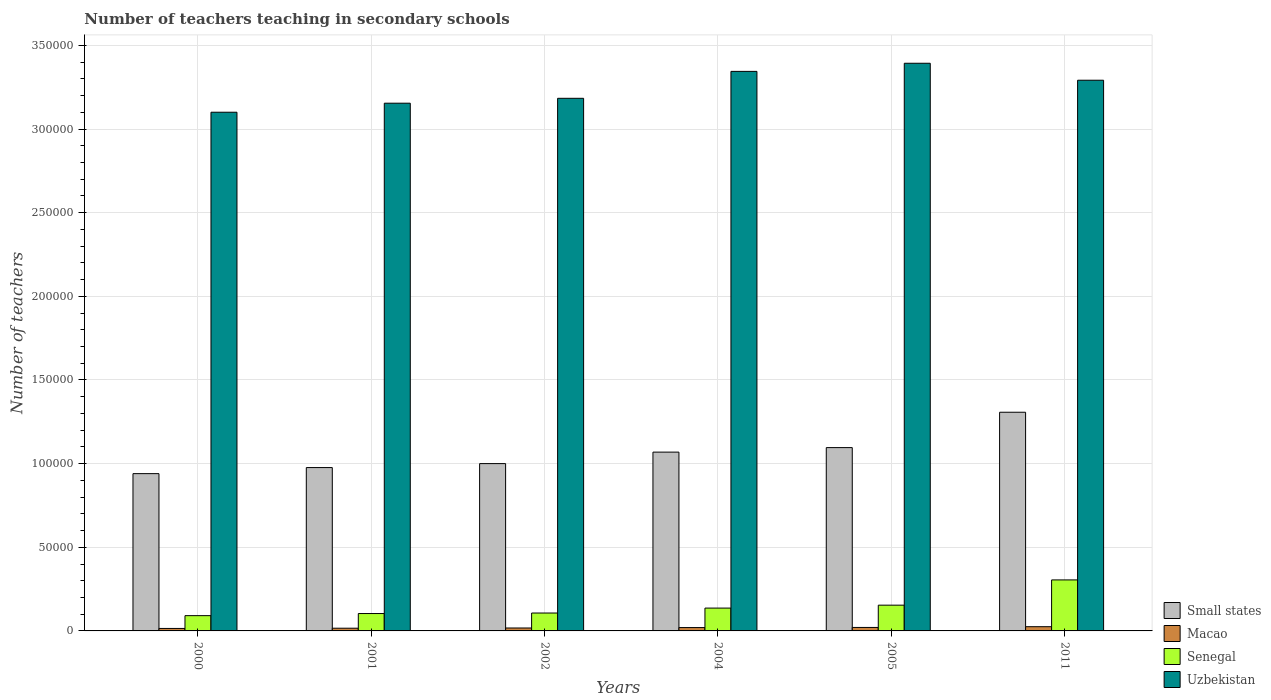How many different coloured bars are there?
Provide a short and direct response. 4. How many bars are there on the 2nd tick from the left?
Provide a short and direct response. 4. What is the number of teachers teaching in secondary schools in Small states in 2001?
Provide a short and direct response. 9.76e+04. Across all years, what is the maximum number of teachers teaching in secondary schools in Small states?
Your answer should be very brief. 1.31e+05. Across all years, what is the minimum number of teachers teaching in secondary schools in Uzbekistan?
Give a very brief answer. 3.10e+05. What is the total number of teachers teaching in secondary schools in Uzbekistan in the graph?
Offer a very short reply. 1.95e+06. What is the difference between the number of teachers teaching in secondary schools in Macao in 2001 and that in 2011?
Offer a very short reply. -902. What is the difference between the number of teachers teaching in secondary schools in Senegal in 2005 and the number of teachers teaching in secondary schools in Macao in 2004?
Your response must be concise. 1.34e+04. What is the average number of teachers teaching in secondary schools in Senegal per year?
Ensure brevity in your answer.  1.50e+04. In the year 2005, what is the difference between the number of teachers teaching in secondary schools in Macao and number of teachers teaching in secondary schools in Senegal?
Your response must be concise. -1.33e+04. In how many years, is the number of teachers teaching in secondary schools in Macao greater than 20000?
Offer a terse response. 0. What is the ratio of the number of teachers teaching in secondary schools in Small states in 2000 to that in 2005?
Offer a very short reply. 0.86. What is the difference between the highest and the second highest number of teachers teaching in secondary schools in Small states?
Keep it short and to the point. 2.11e+04. What is the difference between the highest and the lowest number of teachers teaching in secondary schools in Uzbekistan?
Provide a short and direct response. 2.93e+04. In how many years, is the number of teachers teaching in secondary schools in Macao greater than the average number of teachers teaching in secondary schools in Macao taken over all years?
Keep it short and to the point. 3. What does the 3rd bar from the left in 2000 represents?
Keep it short and to the point. Senegal. What does the 3rd bar from the right in 2000 represents?
Keep it short and to the point. Macao. Is it the case that in every year, the sum of the number of teachers teaching in secondary schools in Small states and number of teachers teaching in secondary schools in Uzbekistan is greater than the number of teachers teaching in secondary schools in Senegal?
Offer a terse response. Yes. Are all the bars in the graph horizontal?
Offer a terse response. No. How many years are there in the graph?
Make the answer very short. 6. What is the difference between two consecutive major ticks on the Y-axis?
Make the answer very short. 5.00e+04. Are the values on the major ticks of Y-axis written in scientific E-notation?
Offer a very short reply. No. Does the graph contain any zero values?
Make the answer very short. No. Where does the legend appear in the graph?
Ensure brevity in your answer.  Bottom right. How are the legend labels stacked?
Your response must be concise. Vertical. What is the title of the graph?
Provide a short and direct response. Number of teachers teaching in secondary schools. What is the label or title of the X-axis?
Make the answer very short. Years. What is the label or title of the Y-axis?
Offer a terse response. Number of teachers. What is the Number of teachers of Small states in 2000?
Your response must be concise. 9.40e+04. What is the Number of teachers of Macao in 2000?
Your response must be concise. 1481. What is the Number of teachers of Senegal in 2000?
Your response must be concise. 9125. What is the Number of teachers in Uzbekistan in 2000?
Make the answer very short. 3.10e+05. What is the Number of teachers of Small states in 2001?
Make the answer very short. 9.76e+04. What is the Number of teachers in Macao in 2001?
Keep it short and to the point. 1621. What is the Number of teachers of Senegal in 2001?
Your answer should be very brief. 1.04e+04. What is the Number of teachers of Uzbekistan in 2001?
Your response must be concise. 3.15e+05. What is the Number of teachers in Small states in 2002?
Provide a short and direct response. 1.00e+05. What is the Number of teachers of Macao in 2002?
Ensure brevity in your answer.  1753. What is the Number of teachers of Senegal in 2002?
Your answer should be compact. 1.07e+04. What is the Number of teachers of Uzbekistan in 2002?
Provide a short and direct response. 3.18e+05. What is the Number of teachers of Small states in 2004?
Offer a terse response. 1.07e+05. What is the Number of teachers of Macao in 2004?
Provide a succinct answer. 2001. What is the Number of teachers in Senegal in 2004?
Give a very brief answer. 1.37e+04. What is the Number of teachers of Uzbekistan in 2004?
Give a very brief answer. 3.34e+05. What is the Number of teachers of Small states in 2005?
Your answer should be very brief. 1.10e+05. What is the Number of teachers of Macao in 2005?
Give a very brief answer. 2077. What is the Number of teachers in Senegal in 2005?
Provide a succinct answer. 1.54e+04. What is the Number of teachers of Uzbekistan in 2005?
Keep it short and to the point. 3.39e+05. What is the Number of teachers of Small states in 2011?
Your answer should be very brief. 1.31e+05. What is the Number of teachers in Macao in 2011?
Offer a very short reply. 2523. What is the Number of teachers in Senegal in 2011?
Provide a succinct answer. 3.05e+04. What is the Number of teachers in Uzbekistan in 2011?
Give a very brief answer. 3.29e+05. Across all years, what is the maximum Number of teachers in Small states?
Keep it short and to the point. 1.31e+05. Across all years, what is the maximum Number of teachers of Macao?
Your answer should be very brief. 2523. Across all years, what is the maximum Number of teachers of Senegal?
Offer a very short reply. 3.05e+04. Across all years, what is the maximum Number of teachers in Uzbekistan?
Keep it short and to the point. 3.39e+05. Across all years, what is the minimum Number of teachers of Small states?
Offer a terse response. 9.40e+04. Across all years, what is the minimum Number of teachers in Macao?
Ensure brevity in your answer.  1481. Across all years, what is the minimum Number of teachers in Senegal?
Make the answer very short. 9125. Across all years, what is the minimum Number of teachers in Uzbekistan?
Offer a very short reply. 3.10e+05. What is the total Number of teachers in Small states in the graph?
Your response must be concise. 6.39e+05. What is the total Number of teachers of Macao in the graph?
Your answer should be very brief. 1.15e+04. What is the total Number of teachers of Senegal in the graph?
Your answer should be compact. 8.98e+04. What is the total Number of teachers of Uzbekistan in the graph?
Offer a very short reply. 1.95e+06. What is the difference between the Number of teachers of Small states in 2000 and that in 2001?
Ensure brevity in your answer.  -3621.86. What is the difference between the Number of teachers in Macao in 2000 and that in 2001?
Keep it short and to the point. -140. What is the difference between the Number of teachers of Senegal in 2000 and that in 2001?
Give a very brief answer. -1266. What is the difference between the Number of teachers of Uzbekistan in 2000 and that in 2001?
Keep it short and to the point. -5396. What is the difference between the Number of teachers of Small states in 2000 and that in 2002?
Make the answer very short. -5992.75. What is the difference between the Number of teachers of Macao in 2000 and that in 2002?
Your response must be concise. -272. What is the difference between the Number of teachers in Senegal in 2000 and that in 2002?
Provide a succinct answer. -1574. What is the difference between the Number of teachers of Uzbekistan in 2000 and that in 2002?
Your response must be concise. -8323. What is the difference between the Number of teachers in Small states in 2000 and that in 2004?
Offer a terse response. -1.29e+04. What is the difference between the Number of teachers in Macao in 2000 and that in 2004?
Offer a terse response. -520. What is the difference between the Number of teachers in Senegal in 2000 and that in 2004?
Keep it short and to the point. -4529. What is the difference between the Number of teachers in Uzbekistan in 2000 and that in 2004?
Give a very brief answer. -2.44e+04. What is the difference between the Number of teachers of Small states in 2000 and that in 2005?
Offer a very short reply. -1.56e+04. What is the difference between the Number of teachers in Macao in 2000 and that in 2005?
Give a very brief answer. -596. What is the difference between the Number of teachers in Senegal in 2000 and that in 2005?
Offer a very short reply. -6269. What is the difference between the Number of teachers of Uzbekistan in 2000 and that in 2005?
Keep it short and to the point. -2.93e+04. What is the difference between the Number of teachers in Small states in 2000 and that in 2011?
Provide a succinct answer. -3.67e+04. What is the difference between the Number of teachers of Macao in 2000 and that in 2011?
Keep it short and to the point. -1042. What is the difference between the Number of teachers in Senegal in 2000 and that in 2011?
Your response must be concise. -2.14e+04. What is the difference between the Number of teachers in Uzbekistan in 2000 and that in 2011?
Your answer should be compact. -1.91e+04. What is the difference between the Number of teachers of Small states in 2001 and that in 2002?
Ensure brevity in your answer.  -2370.89. What is the difference between the Number of teachers in Macao in 2001 and that in 2002?
Offer a terse response. -132. What is the difference between the Number of teachers in Senegal in 2001 and that in 2002?
Ensure brevity in your answer.  -308. What is the difference between the Number of teachers of Uzbekistan in 2001 and that in 2002?
Make the answer very short. -2927. What is the difference between the Number of teachers in Small states in 2001 and that in 2004?
Make the answer very short. -9239.85. What is the difference between the Number of teachers of Macao in 2001 and that in 2004?
Your answer should be very brief. -380. What is the difference between the Number of teachers in Senegal in 2001 and that in 2004?
Give a very brief answer. -3263. What is the difference between the Number of teachers of Uzbekistan in 2001 and that in 2004?
Your answer should be very brief. -1.90e+04. What is the difference between the Number of teachers of Small states in 2001 and that in 2005?
Offer a very short reply. -1.19e+04. What is the difference between the Number of teachers in Macao in 2001 and that in 2005?
Give a very brief answer. -456. What is the difference between the Number of teachers in Senegal in 2001 and that in 2005?
Make the answer very short. -5003. What is the difference between the Number of teachers in Uzbekistan in 2001 and that in 2005?
Keep it short and to the point. -2.39e+04. What is the difference between the Number of teachers of Small states in 2001 and that in 2011?
Your answer should be compact. -3.31e+04. What is the difference between the Number of teachers of Macao in 2001 and that in 2011?
Your response must be concise. -902. What is the difference between the Number of teachers of Senegal in 2001 and that in 2011?
Ensure brevity in your answer.  -2.01e+04. What is the difference between the Number of teachers in Uzbekistan in 2001 and that in 2011?
Offer a very short reply. -1.37e+04. What is the difference between the Number of teachers in Small states in 2002 and that in 2004?
Keep it short and to the point. -6868.96. What is the difference between the Number of teachers of Macao in 2002 and that in 2004?
Your answer should be compact. -248. What is the difference between the Number of teachers in Senegal in 2002 and that in 2004?
Provide a short and direct response. -2955. What is the difference between the Number of teachers of Uzbekistan in 2002 and that in 2004?
Provide a short and direct response. -1.61e+04. What is the difference between the Number of teachers in Small states in 2002 and that in 2005?
Your answer should be very brief. -9563.68. What is the difference between the Number of teachers in Macao in 2002 and that in 2005?
Give a very brief answer. -324. What is the difference between the Number of teachers in Senegal in 2002 and that in 2005?
Keep it short and to the point. -4695. What is the difference between the Number of teachers in Uzbekistan in 2002 and that in 2005?
Keep it short and to the point. -2.09e+04. What is the difference between the Number of teachers of Small states in 2002 and that in 2011?
Your answer should be compact. -3.07e+04. What is the difference between the Number of teachers of Macao in 2002 and that in 2011?
Your answer should be very brief. -770. What is the difference between the Number of teachers of Senegal in 2002 and that in 2011?
Give a very brief answer. -1.98e+04. What is the difference between the Number of teachers in Uzbekistan in 2002 and that in 2011?
Provide a short and direct response. -1.08e+04. What is the difference between the Number of teachers of Small states in 2004 and that in 2005?
Make the answer very short. -2694.72. What is the difference between the Number of teachers in Macao in 2004 and that in 2005?
Give a very brief answer. -76. What is the difference between the Number of teachers of Senegal in 2004 and that in 2005?
Your response must be concise. -1740. What is the difference between the Number of teachers in Uzbekistan in 2004 and that in 2005?
Keep it short and to the point. -4854. What is the difference between the Number of teachers in Small states in 2004 and that in 2011?
Your answer should be very brief. -2.38e+04. What is the difference between the Number of teachers in Macao in 2004 and that in 2011?
Your answer should be very brief. -522. What is the difference between the Number of teachers in Senegal in 2004 and that in 2011?
Provide a short and direct response. -1.68e+04. What is the difference between the Number of teachers of Uzbekistan in 2004 and that in 2011?
Your answer should be compact. 5293. What is the difference between the Number of teachers in Small states in 2005 and that in 2011?
Make the answer very short. -2.11e+04. What is the difference between the Number of teachers in Macao in 2005 and that in 2011?
Offer a terse response. -446. What is the difference between the Number of teachers of Senegal in 2005 and that in 2011?
Your answer should be very brief. -1.51e+04. What is the difference between the Number of teachers in Uzbekistan in 2005 and that in 2011?
Make the answer very short. 1.01e+04. What is the difference between the Number of teachers of Small states in 2000 and the Number of teachers of Macao in 2001?
Your answer should be very brief. 9.24e+04. What is the difference between the Number of teachers in Small states in 2000 and the Number of teachers in Senegal in 2001?
Your response must be concise. 8.36e+04. What is the difference between the Number of teachers in Small states in 2000 and the Number of teachers in Uzbekistan in 2001?
Your response must be concise. -2.21e+05. What is the difference between the Number of teachers in Macao in 2000 and the Number of teachers in Senegal in 2001?
Your answer should be compact. -8910. What is the difference between the Number of teachers in Macao in 2000 and the Number of teachers in Uzbekistan in 2001?
Keep it short and to the point. -3.14e+05. What is the difference between the Number of teachers of Senegal in 2000 and the Number of teachers of Uzbekistan in 2001?
Your answer should be compact. -3.06e+05. What is the difference between the Number of teachers in Small states in 2000 and the Number of teachers in Macao in 2002?
Your answer should be very brief. 9.23e+04. What is the difference between the Number of teachers of Small states in 2000 and the Number of teachers of Senegal in 2002?
Your answer should be very brief. 8.33e+04. What is the difference between the Number of teachers of Small states in 2000 and the Number of teachers of Uzbekistan in 2002?
Your answer should be very brief. -2.24e+05. What is the difference between the Number of teachers of Macao in 2000 and the Number of teachers of Senegal in 2002?
Keep it short and to the point. -9218. What is the difference between the Number of teachers of Macao in 2000 and the Number of teachers of Uzbekistan in 2002?
Give a very brief answer. -3.17e+05. What is the difference between the Number of teachers of Senegal in 2000 and the Number of teachers of Uzbekistan in 2002?
Provide a short and direct response. -3.09e+05. What is the difference between the Number of teachers in Small states in 2000 and the Number of teachers in Macao in 2004?
Provide a succinct answer. 9.20e+04. What is the difference between the Number of teachers in Small states in 2000 and the Number of teachers in Senegal in 2004?
Your answer should be very brief. 8.04e+04. What is the difference between the Number of teachers of Small states in 2000 and the Number of teachers of Uzbekistan in 2004?
Your response must be concise. -2.40e+05. What is the difference between the Number of teachers of Macao in 2000 and the Number of teachers of Senegal in 2004?
Offer a very short reply. -1.22e+04. What is the difference between the Number of teachers in Macao in 2000 and the Number of teachers in Uzbekistan in 2004?
Make the answer very short. -3.33e+05. What is the difference between the Number of teachers in Senegal in 2000 and the Number of teachers in Uzbekistan in 2004?
Offer a very short reply. -3.25e+05. What is the difference between the Number of teachers in Small states in 2000 and the Number of teachers in Macao in 2005?
Your response must be concise. 9.19e+04. What is the difference between the Number of teachers in Small states in 2000 and the Number of teachers in Senegal in 2005?
Offer a very short reply. 7.86e+04. What is the difference between the Number of teachers in Small states in 2000 and the Number of teachers in Uzbekistan in 2005?
Make the answer very short. -2.45e+05. What is the difference between the Number of teachers of Macao in 2000 and the Number of teachers of Senegal in 2005?
Your answer should be very brief. -1.39e+04. What is the difference between the Number of teachers of Macao in 2000 and the Number of teachers of Uzbekistan in 2005?
Provide a short and direct response. -3.38e+05. What is the difference between the Number of teachers of Senegal in 2000 and the Number of teachers of Uzbekistan in 2005?
Offer a very short reply. -3.30e+05. What is the difference between the Number of teachers in Small states in 2000 and the Number of teachers in Macao in 2011?
Provide a succinct answer. 9.15e+04. What is the difference between the Number of teachers of Small states in 2000 and the Number of teachers of Senegal in 2011?
Keep it short and to the point. 6.35e+04. What is the difference between the Number of teachers in Small states in 2000 and the Number of teachers in Uzbekistan in 2011?
Offer a terse response. -2.35e+05. What is the difference between the Number of teachers in Macao in 2000 and the Number of teachers in Senegal in 2011?
Offer a terse response. -2.90e+04. What is the difference between the Number of teachers in Macao in 2000 and the Number of teachers in Uzbekistan in 2011?
Make the answer very short. -3.28e+05. What is the difference between the Number of teachers of Senegal in 2000 and the Number of teachers of Uzbekistan in 2011?
Your response must be concise. -3.20e+05. What is the difference between the Number of teachers in Small states in 2001 and the Number of teachers in Macao in 2002?
Make the answer very short. 9.59e+04. What is the difference between the Number of teachers of Small states in 2001 and the Number of teachers of Senegal in 2002?
Ensure brevity in your answer.  8.69e+04. What is the difference between the Number of teachers in Small states in 2001 and the Number of teachers in Uzbekistan in 2002?
Provide a short and direct response. -2.21e+05. What is the difference between the Number of teachers of Macao in 2001 and the Number of teachers of Senegal in 2002?
Ensure brevity in your answer.  -9078. What is the difference between the Number of teachers in Macao in 2001 and the Number of teachers in Uzbekistan in 2002?
Your answer should be very brief. -3.17e+05. What is the difference between the Number of teachers of Senegal in 2001 and the Number of teachers of Uzbekistan in 2002?
Ensure brevity in your answer.  -3.08e+05. What is the difference between the Number of teachers of Small states in 2001 and the Number of teachers of Macao in 2004?
Ensure brevity in your answer.  9.56e+04. What is the difference between the Number of teachers of Small states in 2001 and the Number of teachers of Senegal in 2004?
Give a very brief answer. 8.40e+04. What is the difference between the Number of teachers of Small states in 2001 and the Number of teachers of Uzbekistan in 2004?
Your response must be concise. -2.37e+05. What is the difference between the Number of teachers in Macao in 2001 and the Number of teachers in Senegal in 2004?
Your answer should be compact. -1.20e+04. What is the difference between the Number of teachers in Macao in 2001 and the Number of teachers in Uzbekistan in 2004?
Your answer should be compact. -3.33e+05. What is the difference between the Number of teachers of Senegal in 2001 and the Number of teachers of Uzbekistan in 2004?
Offer a terse response. -3.24e+05. What is the difference between the Number of teachers in Small states in 2001 and the Number of teachers in Macao in 2005?
Offer a terse response. 9.56e+04. What is the difference between the Number of teachers of Small states in 2001 and the Number of teachers of Senegal in 2005?
Offer a very short reply. 8.22e+04. What is the difference between the Number of teachers of Small states in 2001 and the Number of teachers of Uzbekistan in 2005?
Offer a terse response. -2.42e+05. What is the difference between the Number of teachers in Macao in 2001 and the Number of teachers in Senegal in 2005?
Give a very brief answer. -1.38e+04. What is the difference between the Number of teachers in Macao in 2001 and the Number of teachers in Uzbekistan in 2005?
Provide a succinct answer. -3.38e+05. What is the difference between the Number of teachers of Senegal in 2001 and the Number of teachers of Uzbekistan in 2005?
Your answer should be very brief. -3.29e+05. What is the difference between the Number of teachers of Small states in 2001 and the Number of teachers of Macao in 2011?
Keep it short and to the point. 9.51e+04. What is the difference between the Number of teachers of Small states in 2001 and the Number of teachers of Senegal in 2011?
Ensure brevity in your answer.  6.72e+04. What is the difference between the Number of teachers of Small states in 2001 and the Number of teachers of Uzbekistan in 2011?
Make the answer very short. -2.32e+05. What is the difference between the Number of teachers in Macao in 2001 and the Number of teachers in Senegal in 2011?
Give a very brief answer. -2.89e+04. What is the difference between the Number of teachers in Macao in 2001 and the Number of teachers in Uzbekistan in 2011?
Give a very brief answer. -3.28e+05. What is the difference between the Number of teachers of Senegal in 2001 and the Number of teachers of Uzbekistan in 2011?
Offer a very short reply. -3.19e+05. What is the difference between the Number of teachers in Small states in 2002 and the Number of teachers in Macao in 2004?
Ensure brevity in your answer.  9.80e+04. What is the difference between the Number of teachers in Small states in 2002 and the Number of teachers in Senegal in 2004?
Provide a short and direct response. 8.64e+04. What is the difference between the Number of teachers of Small states in 2002 and the Number of teachers of Uzbekistan in 2004?
Provide a succinct answer. -2.34e+05. What is the difference between the Number of teachers in Macao in 2002 and the Number of teachers in Senegal in 2004?
Make the answer very short. -1.19e+04. What is the difference between the Number of teachers in Macao in 2002 and the Number of teachers in Uzbekistan in 2004?
Ensure brevity in your answer.  -3.33e+05. What is the difference between the Number of teachers in Senegal in 2002 and the Number of teachers in Uzbekistan in 2004?
Ensure brevity in your answer.  -3.24e+05. What is the difference between the Number of teachers in Small states in 2002 and the Number of teachers in Macao in 2005?
Make the answer very short. 9.79e+04. What is the difference between the Number of teachers in Small states in 2002 and the Number of teachers in Senegal in 2005?
Provide a short and direct response. 8.46e+04. What is the difference between the Number of teachers of Small states in 2002 and the Number of teachers of Uzbekistan in 2005?
Ensure brevity in your answer.  -2.39e+05. What is the difference between the Number of teachers in Macao in 2002 and the Number of teachers in Senegal in 2005?
Offer a very short reply. -1.36e+04. What is the difference between the Number of teachers of Macao in 2002 and the Number of teachers of Uzbekistan in 2005?
Offer a very short reply. -3.38e+05. What is the difference between the Number of teachers of Senegal in 2002 and the Number of teachers of Uzbekistan in 2005?
Provide a short and direct response. -3.29e+05. What is the difference between the Number of teachers in Small states in 2002 and the Number of teachers in Macao in 2011?
Offer a very short reply. 9.75e+04. What is the difference between the Number of teachers of Small states in 2002 and the Number of teachers of Senegal in 2011?
Your response must be concise. 6.95e+04. What is the difference between the Number of teachers of Small states in 2002 and the Number of teachers of Uzbekistan in 2011?
Your response must be concise. -2.29e+05. What is the difference between the Number of teachers of Macao in 2002 and the Number of teachers of Senegal in 2011?
Your response must be concise. -2.87e+04. What is the difference between the Number of teachers in Macao in 2002 and the Number of teachers in Uzbekistan in 2011?
Provide a succinct answer. -3.27e+05. What is the difference between the Number of teachers in Senegal in 2002 and the Number of teachers in Uzbekistan in 2011?
Your answer should be very brief. -3.18e+05. What is the difference between the Number of teachers of Small states in 2004 and the Number of teachers of Macao in 2005?
Keep it short and to the point. 1.05e+05. What is the difference between the Number of teachers in Small states in 2004 and the Number of teachers in Senegal in 2005?
Give a very brief answer. 9.15e+04. What is the difference between the Number of teachers of Small states in 2004 and the Number of teachers of Uzbekistan in 2005?
Make the answer very short. -2.32e+05. What is the difference between the Number of teachers of Macao in 2004 and the Number of teachers of Senegal in 2005?
Offer a very short reply. -1.34e+04. What is the difference between the Number of teachers of Macao in 2004 and the Number of teachers of Uzbekistan in 2005?
Give a very brief answer. -3.37e+05. What is the difference between the Number of teachers of Senegal in 2004 and the Number of teachers of Uzbekistan in 2005?
Provide a short and direct response. -3.26e+05. What is the difference between the Number of teachers in Small states in 2004 and the Number of teachers in Macao in 2011?
Provide a short and direct response. 1.04e+05. What is the difference between the Number of teachers of Small states in 2004 and the Number of teachers of Senegal in 2011?
Provide a short and direct response. 7.64e+04. What is the difference between the Number of teachers of Small states in 2004 and the Number of teachers of Uzbekistan in 2011?
Ensure brevity in your answer.  -2.22e+05. What is the difference between the Number of teachers of Macao in 2004 and the Number of teachers of Senegal in 2011?
Your answer should be very brief. -2.85e+04. What is the difference between the Number of teachers of Macao in 2004 and the Number of teachers of Uzbekistan in 2011?
Your answer should be very brief. -3.27e+05. What is the difference between the Number of teachers in Senegal in 2004 and the Number of teachers in Uzbekistan in 2011?
Offer a very short reply. -3.16e+05. What is the difference between the Number of teachers in Small states in 2005 and the Number of teachers in Macao in 2011?
Your answer should be very brief. 1.07e+05. What is the difference between the Number of teachers in Small states in 2005 and the Number of teachers in Senegal in 2011?
Provide a succinct answer. 7.91e+04. What is the difference between the Number of teachers of Small states in 2005 and the Number of teachers of Uzbekistan in 2011?
Your answer should be very brief. -2.20e+05. What is the difference between the Number of teachers of Macao in 2005 and the Number of teachers of Senegal in 2011?
Offer a very short reply. -2.84e+04. What is the difference between the Number of teachers in Macao in 2005 and the Number of teachers in Uzbekistan in 2011?
Ensure brevity in your answer.  -3.27e+05. What is the difference between the Number of teachers in Senegal in 2005 and the Number of teachers in Uzbekistan in 2011?
Your response must be concise. -3.14e+05. What is the average Number of teachers in Small states per year?
Provide a succinct answer. 1.06e+05. What is the average Number of teachers in Macao per year?
Offer a terse response. 1909.33. What is the average Number of teachers of Senegal per year?
Your answer should be very brief. 1.50e+04. What is the average Number of teachers in Uzbekistan per year?
Your answer should be compact. 3.24e+05. In the year 2000, what is the difference between the Number of teachers in Small states and Number of teachers in Macao?
Your answer should be very brief. 9.25e+04. In the year 2000, what is the difference between the Number of teachers in Small states and Number of teachers in Senegal?
Give a very brief answer. 8.49e+04. In the year 2000, what is the difference between the Number of teachers in Small states and Number of teachers in Uzbekistan?
Provide a succinct answer. -2.16e+05. In the year 2000, what is the difference between the Number of teachers in Macao and Number of teachers in Senegal?
Offer a terse response. -7644. In the year 2000, what is the difference between the Number of teachers in Macao and Number of teachers in Uzbekistan?
Keep it short and to the point. -3.09e+05. In the year 2000, what is the difference between the Number of teachers in Senegal and Number of teachers in Uzbekistan?
Your answer should be very brief. -3.01e+05. In the year 2001, what is the difference between the Number of teachers of Small states and Number of teachers of Macao?
Your response must be concise. 9.60e+04. In the year 2001, what is the difference between the Number of teachers of Small states and Number of teachers of Senegal?
Keep it short and to the point. 8.73e+04. In the year 2001, what is the difference between the Number of teachers of Small states and Number of teachers of Uzbekistan?
Make the answer very short. -2.18e+05. In the year 2001, what is the difference between the Number of teachers of Macao and Number of teachers of Senegal?
Your answer should be very brief. -8770. In the year 2001, what is the difference between the Number of teachers in Macao and Number of teachers in Uzbekistan?
Your answer should be compact. -3.14e+05. In the year 2001, what is the difference between the Number of teachers of Senegal and Number of teachers of Uzbekistan?
Provide a succinct answer. -3.05e+05. In the year 2002, what is the difference between the Number of teachers of Small states and Number of teachers of Macao?
Ensure brevity in your answer.  9.83e+04. In the year 2002, what is the difference between the Number of teachers of Small states and Number of teachers of Senegal?
Your answer should be very brief. 8.93e+04. In the year 2002, what is the difference between the Number of teachers of Small states and Number of teachers of Uzbekistan?
Make the answer very short. -2.18e+05. In the year 2002, what is the difference between the Number of teachers of Macao and Number of teachers of Senegal?
Your response must be concise. -8946. In the year 2002, what is the difference between the Number of teachers in Macao and Number of teachers in Uzbekistan?
Ensure brevity in your answer.  -3.17e+05. In the year 2002, what is the difference between the Number of teachers of Senegal and Number of teachers of Uzbekistan?
Provide a succinct answer. -3.08e+05. In the year 2004, what is the difference between the Number of teachers of Small states and Number of teachers of Macao?
Provide a short and direct response. 1.05e+05. In the year 2004, what is the difference between the Number of teachers in Small states and Number of teachers in Senegal?
Your response must be concise. 9.32e+04. In the year 2004, what is the difference between the Number of teachers in Small states and Number of teachers in Uzbekistan?
Provide a succinct answer. -2.28e+05. In the year 2004, what is the difference between the Number of teachers of Macao and Number of teachers of Senegal?
Make the answer very short. -1.17e+04. In the year 2004, what is the difference between the Number of teachers of Macao and Number of teachers of Uzbekistan?
Your answer should be very brief. -3.32e+05. In the year 2004, what is the difference between the Number of teachers in Senegal and Number of teachers in Uzbekistan?
Give a very brief answer. -3.21e+05. In the year 2005, what is the difference between the Number of teachers of Small states and Number of teachers of Macao?
Provide a short and direct response. 1.08e+05. In the year 2005, what is the difference between the Number of teachers in Small states and Number of teachers in Senegal?
Keep it short and to the point. 9.42e+04. In the year 2005, what is the difference between the Number of teachers in Small states and Number of teachers in Uzbekistan?
Provide a short and direct response. -2.30e+05. In the year 2005, what is the difference between the Number of teachers of Macao and Number of teachers of Senegal?
Provide a short and direct response. -1.33e+04. In the year 2005, what is the difference between the Number of teachers of Macao and Number of teachers of Uzbekistan?
Provide a short and direct response. -3.37e+05. In the year 2005, what is the difference between the Number of teachers in Senegal and Number of teachers in Uzbekistan?
Give a very brief answer. -3.24e+05. In the year 2011, what is the difference between the Number of teachers of Small states and Number of teachers of Macao?
Offer a very short reply. 1.28e+05. In the year 2011, what is the difference between the Number of teachers of Small states and Number of teachers of Senegal?
Keep it short and to the point. 1.00e+05. In the year 2011, what is the difference between the Number of teachers in Small states and Number of teachers in Uzbekistan?
Keep it short and to the point. -1.98e+05. In the year 2011, what is the difference between the Number of teachers in Macao and Number of teachers in Senegal?
Your answer should be very brief. -2.80e+04. In the year 2011, what is the difference between the Number of teachers of Macao and Number of teachers of Uzbekistan?
Your answer should be very brief. -3.27e+05. In the year 2011, what is the difference between the Number of teachers of Senegal and Number of teachers of Uzbekistan?
Offer a terse response. -2.99e+05. What is the ratio of the Number of teachers in Small states in 2000 to that in 2001?
Give a very brief answer. 0.96. What is the ratio of the Number of teachers of Macao in 2000 to that in 2001?
Your answer should be compact. 0.91. What is the ratio of the Number of teachers of Senegal in 2000 to that in 2001?
Offer a terse response. 0.88. What is the ratio of the Number of teachers of Uzbekistan in 2000 to that in 2001?
Give a very brief answer. 0.98. What is the ratio of the Number of teachers of Small states in 2000 to that in 2002?
Provide a short and direct response. 0.94. What is the ratio of the Number of teachers in Macao in 2000 to that in 2002?
Your answer should be compact. 0.84. What is the ratio of the Number of teachers of Senegal in 2000 to that in 2002?
Your response must be concise. 0.85. What is the ratio of the Number of teachers in Uzbekistan in 2000 to that in 2002?
Provide a short and direct response. 0.97. What is the ratio of the Number of teachers of Small states in 2000 to that in 2004?
Your answer should be compact. 0.88. What is the ratio of the Number of teachers in Macao in 2000 to that in 2004?
Your answer should be compact. 0.74. What is the ratio of the Number of teachers of Senegal in 2000 to that in 2004?
Make the answer very short. 0.67. What is the ratio of the Number of teachers in Uzbekistan in 2000 to that in 2004?
Provide a succinct answer. 0.93. What is the ratio of the Number of teachers of Small states in 2000 to that in 2005?
Provide a succinct answer. 0.86. What is the ratio of the Number of teachers in Macao in 2000 to that in 2005?
Keep it short and to the point. 0.71. What is the ratio of the Number of teachers in Senegal in 2000 to that in 2005?
Offer a very short reply. 0.59. What is the ratio of the Number of teachers in Uzbekistan in 2000 to that in 2005?
Your answer should be very brief. 0.91. What is the ratio of the Number of teachers in Small states in 2000 to that in 2011?
Your answer should be very brief. 0.72. What is the ratio of the Number of teachers of Macao in 2000 to that in 2011?
Give a very brief answer. 0.59. What is the ratio of the Number of teachers of Senegal in 2000 to that in 2011?
Provide a succinct answer. 0.3. What is the ratio of the Number of teachers in Uzbekistan in 2000 to that in 2011?
Your answer should be compact. 0.94. What is the ratio of the Number of teachers of Small states in 2001 to that in 2002?
Your response must be concise. 0.98. What is the ratio of the Number of teachers in Macao in 2001 to that in 2002?
Ensure brevity in your answer.  0.92. What is the ratio of the Number of teachers of Senegal in 2001 to that in 2002?
Make the answer very short. 0.97. What is the ratio of the Number of teachers in Uzbekistan in 2001 to that in 2002?
Provide a succinct answer. 0.99. What is the ratio of the Number of teachers in Small states in 2001 to that in 2004?
Offer a very short reply. 0.91. What is the ratio of the Number of teachers of Macao in 2001 to that in 2004?
Your response must be concise. 0.81. What is the ratio of the Number of teachers in Senegal in 2001 to that in 2004?
Provide a succinct answer. 0.76. What is the ratio of the Number of teachers in Uzbekistan in 2001 to that in 2004?
Ensure brevity in your answer.  0.94. What is the ratio of the Number of teachers in Small states in 2001 to that in 2005?
Provide a succinct answer. 0.89. What is the ratio of the Number of teachers of Macao in 2001 to that in 2005?
Offer a terse response. 0.78. What is the ratio of the Number of teachers of Senegal in 2001 to that in 2005?
Offer a very short reply. 0.68. What is the ratio of the Number of teachers in Uzbekistan in 2001 to that in 2005?
Give a very brief answer. 0.93. What is the ratio of the Number of teachers in Small states in 2001 to that in 2011?
Offer a terse response. 0.75. What is the ratio of the Number of teachers in Macao in 2001 to that in 2011?
Your response must be concise. 0.64. What is the ratio of the Number of teachers in Senegal in 2001 to that in 2011?
Ensure brevity in your answer.  0.34. What is the ratio of the Number of teachers of Uzbekistan in 2001 to that in 2011?
Make the answer very short. 0.96. What is the ratio of the Number of teachers of Small states in 2002 to that in 2004?
Offer a very short reply. 0.94. What is the ratio of the Number of teachers in Macao in 2002 to that in 2004?
Provide a short and direct response. 0.88. What is the ratio of the Number of teachers in Senegal in 2002 to that in 2004?
Your answer should be very brief. 0.78. What is the ratio of the Number of teachers of Uzbekistan in 2002 to that in 2004?
Offer a very short reply. 0.95. What is the ratio of the Number of teachers in Small states in 2002 to that in 2005?
Your response must be concise. 0.91. What is the ratio of the Number of teachers in Macao in 2002 to that in 2005?
Make the answer very short. 0.84. What is the ratio of the Number of teachers in Senegal in 2002 to that in 2005?
Offer a terse response. 0.69. What is the ratio of the Number of teachers in Uzbekistan in 2002 to that in 2005?
Offer a very short reply. 0.94. What is the ratio of the Number of teachers of Small states in 2002 to that in 2011?
Your answer should be very brief. 0.77. What is the ratio of the Number of teachers in Macao in 2002 to that in 2011?
Offer a very short reply. 0.69. What is the ratio of the Number of teachers in Senegal in 2002 to that in 2011?
Make the answer very short. 0.35. What is the ratio of the Number of teachers of Uzbekistan in 2002 to that in 2011?
Provide a short and direct response. 0.97. What is the ratio of the Number of teachers in Small states in 2004 to that in 2005?
Offer a very short reply. 0.98. What is the ratio of the Number of teachers in Macao in 2004 to that in 2005?
Ensure brevity in your answer.  0.96. What is the ratio of the Number of teachers in Senegal in 2004 to that in 2005?
Ensure brevity in your answer.  0.89. What is the ratio of the Number of teachers in Uzbekistan in 2004 to that in 2005?
Your answer should be compact. 0.99. What is the ratio of the Number of teachers of Small states in 2004 to that in 2011?
Your response must be concise. 0.82. What is the ratio of the Number of teachers of Macao in 2004 to that in 2011?
Provide a succinct answer. 0.79. What is the ratio of the Number of teachers in Senegal in 2004 to that in 2011?
Provide a short and direct response. 0.45. What is the ratio of the Number of teachers in Uzbekistan in 2004 to that in 2011?
Your answer should be compact. 1.02. What is the ratio of the Number of teachers in Small states in 2005 to that in 2011?
Give a very brief answer. 0.84. What is the ratio of the Number of teachers in Macao in 2005 to that in 2011?
Provide a succinct answer. 0.82. What is the ratio of the Number of teachers in Senegal in 2005 to that in 2011?
Provide a short and direct response. 0.5. What is the ratio of the Number of teachers in Uzbekistan in 2005 to that in 2011?
Keep it short and to the point. 1.03. What is the difference between the highest and the second highest Number of teachers in Small states?
Offer a very short reply. 2.11e+04. What is the difference between the highest and the second highest Number of teachers of Macao?
Offer a very short reply. 446. What is the difference between the highest and the second highest Number of teachers in Senegal?
Offer a very short reply. 1.51e+04. What is the difference between the highest and the second highest Number of teachers in Uzbekistan?
Make the answer very short. 4854. What is the difference between the highest and the lowest Number of teachers of Small states?
Make the answer very short. 3.67e+04. What is the difference between the highest and the lowest Number of teachers in Macao?
Keep it short and to the point. 1042. What is the difference between the highest and the lowest Number of teachers of Senegal?
Your response must be concise. 2.14e+04. What is the difference between the highest and the lowest Number of teachers of Uzbekistan?
Give a very brief answer. 2.93e+04. 